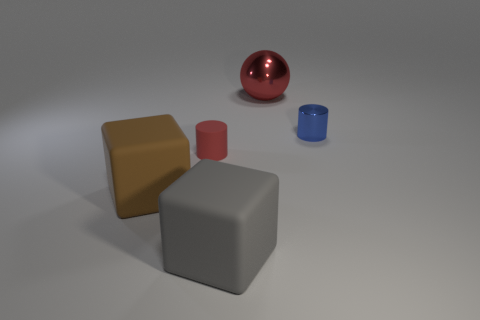Add 3 blue shiny things. How many objects exist? 8 Subtract 0 green spheres. How many objects are left? 5 Subtract all cylinders. How many objects are left? 3 Subtract all blue cylinders. Subtract all red blocks. How many cylinders are left? 1 Subtract all metallic spheres. Subtract all yellow spheres. How many objects are left? 4 Add 5 blue things. How many blue things are left? 6 Add 5 brown cubes. How many brown cubes exist? 6 